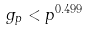<formula> <loc_0><loc_0><loc_500><loc_500>g _ { p } < p ^ { 0 . 4 9 9 }</formula> 